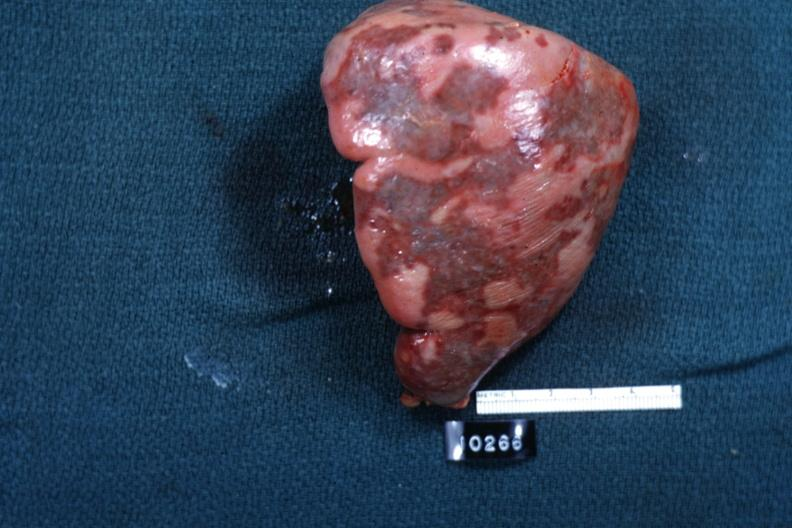s hematologic present?
Answer the question using a single word or phrase. Yes 